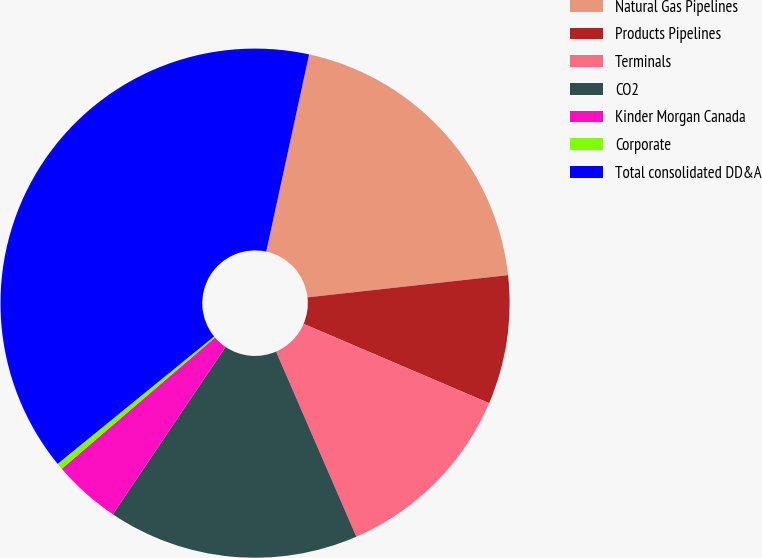Convert chart. <chart><loc_0><loc_0><loc_500><loc_500><pie_chart><fcel>Natural Gas Pipelines<fcel>Products Pipelines<fcel>Terminals<fcel>CO2<fcel>Kinder Morgan Canada<fcel>Corporate<fcel>Total consolidated DD&A<nl><fcel>19.84%<fcel>8.18%<fcel>12.06%<fcel>15.95%<fcel>4.29%<fcel>0.4%<fcel>39.28%<nl></chart> 